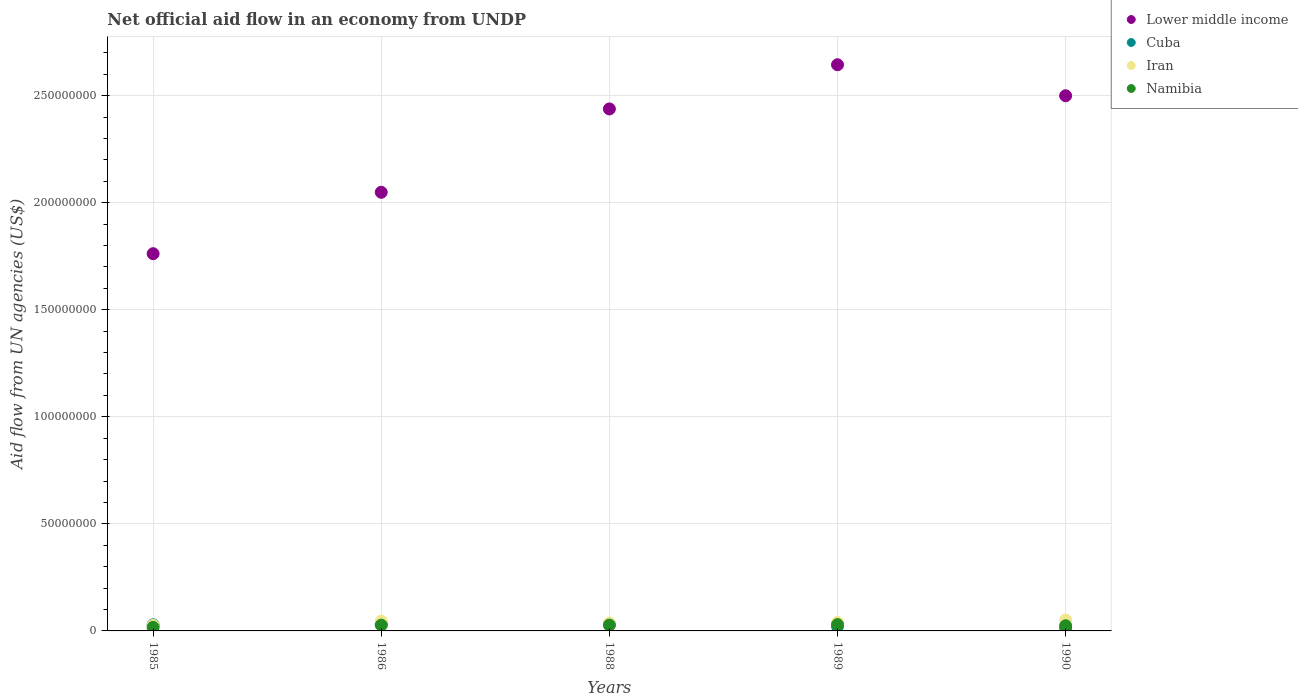What is the net official aid flow in Namibia in 1988?
Your response must be concise. 2.71e+06. Across all years, what is the maximum net official aid flow in Cuba?
Offer a terse response. 3.24e+06. Across all years, what is the minimum net official aid flow in Iran?
Give a very brief answer. 2.56e+06. What is the total net official aid flow in Cuba in the graph?
Provide a succinct answer. 1.27e+07. What is the difference between the net official aid flow in Lower middle income in 1985 and that in 1986?
Make the answer very short. -2.87e+07. What is the difference between the net official aid flow in Namibia in 1989 and the net official aid flow in Cuba in 1990?
Provide a short and direct response. 1.66e+06. What is the average net official aid flow in Lower middle income per year?
Offer a very short reply. 2.28e+08. In the year 1989, what is the difference between the net official aid flow in Iran and net official aid flow in Cuba?
Keep it short and to the point. 1.77e+06. What is the ratio of the net official aid flow in Namibia in 1989 to that in 1990?
Make the answer very short. 1.23. Is the difference between the net official aid flow in Iran in 1986 and 1989 greater than the difference between the net official aid flow in Cuba in 1986 and 1989?
Make the answer very short. No. What is the difference between the highest and the second highest net official aid flow in Lower middle income?
Provide a short and direct response. 1.45e+07. What is the difference between the highest and the lowest net official aid flow in Iran?
Give a very brief answer. 2.55e+06. In how many years, is the net official aid flow in Cuba greater than the average net official aid flow in Cuba taken over all years?
Provide a succinct answer. 3. Is the sum of the net official aid flow in Namibia in 1985 and 1989 greater than the maximum net official aid flow in Lower middle income across all years?
Keep it short and to the point. No. Is it the case that in every year, the sum of the net official aid flow in Iran and net official aid flow in Namibia  is greater than the net official aid flow in Lower middle income?
Give a very brief answer. No. Does the net official aid flow in Cuba monotonically increase over the years?
Offer a terse response. No. Is the net official aid flow in Namibia strictly greater than the net official aid flow in Lower middle income over the years?
Provide a short and direct response. No. Is the net official aid flow in Iran strictly less than the net official aid flow in Namibia over the years?
Give a very brief answer. No. How many dotlines are there?
Offer a terse response. 4. How many years are there in the graph?
Your answer should be very brief. 5. Are the values on the major ticks of Y-axis written in scientific E-notation?
Provide a succinct answer. No. Does the graph contain grids?
Your answer should be very brief. Yes. How are the legend labels stacked?
Your answer should be compact. Vertical. What is the title of the graph?
Make the answer very short. Net official aid flow in an economy from UNDP. What is the label or title of the X-axis?
Offer a terse response. Years. What is the label or title of the Y-axis?
Your answer should be very brief. Aid flow from UN agencies (US$). What is the Aid flow from UN agencies (US$) of Lower middle income in 1985?
Give a very brief answer. 1.76e+08. What is the Aid flow from UN agencies (US$) in Cuba in 1985?
Offer a terse response. 2.86e+06. What is the Aid flow from UN agencies (US$) of Iran in 1985?
Your response must be concise. 2.56e+06. What is the Aid flow from UN agencies (US$) in Namibia in 1985?
Offer a very short reply. 1.66e+06. What is the Aid flow from UN agencies (US$) in Lower middle income in 1986?
Offer a terse response. 2.05e+08. What is the Aid flow from UN agencies (US$) in Cuba in 1986?
Make the answer very short. 3.24e+06. What is the Aid flow from UN agencies (US$) of Iran in 1986?
Keep it short and to the point. 4.57e+06. What is the Aid flow from UN agencies (US$) in Namibia in 1986?
Make the answer very short. 2.71e+06. What is the Aid flow from UN agencies (US$) in Lower middle income in 1988?
Keep it short and to the point. 2.44e+08. What is the Aid flow from UN agencies (US$) in Cuba in 1988?
Your answer should be compact. 3.16e+06. What is the Aid flow from UN agencies (US$) of Iran in 1988?
Keep it short and to the point. 3.69e+06. What is the Aid flow from UN agencies (US$) in Namibia in 1988?
Your response must be concise. 2.71e+06. What is the Aid flow from UN agencies (US$) in Lower middle income in 1989?
Provide a short and direct response. 2.64e+08. What is the Aid flow from UN agencies (US$) in Cuba in 1989?
Provide a short and direct response. 2.15e+06. What is the Aid flow from UN agencies (US$) in Iran in 1989?
Provide a short and direct response. 3.92e+06. What is the Aid flow from UN agencies (US$) of Namibia in 1989?
Ensure brevity in your answer.  2.96e+06. What is the Aid flow from UN agencies (US$) of Lower middle income in 1990?
Offer a terse response. 2.50e+08. What is the Aid flow from UN agencies (US$) in Cuba in 1990?
Your response must be concise. 1.30e+06. What is the Aid flow from UN agencies (US$) in Iran in 1990?
Offer a very short reply. 5.11e+06. What is the Aid flow from UN agencies (US$) of Namibia in 1990?
Your answer should be very brief. 2.41e+06. Across all years, what is the maximum Aid flow from UN agencies (US$) of Lower middle income?
Offer a terse response. 2.64e+08. Across all years, what is the maximum Aid flow from UN agencies (US$) of Cuba?
Offer a very short reply. 3.24e+06. Across all years, what is the maximum Aid flow from UN agencies (US$) in Iran?
Your answer should be very brief. 5.11e+06. Across all years, what is the maximum Aid flow from UN agencies (US$) in Namibia?
Provide a succinct answer. 2.96e+06. Across all years, what is the minimum Aid flow from UN agencies (US$) in Lower middle income?
Give a very brief answer. 1.76e+08. Across all years, what is the minimum Aid flow from UN agencies (US$) of Cuba?
Keep it short and to the point. 1.30e+06. Across all years, what is the minimum Aid flow from UN agencies (US$) of Iran?
Your answer should be compact. 2.56e+06. Across all years, what is the minimum Aid flow from UN agencies (US$) of Namibia?
Your response must be concise. 1.66e+06. What is the total Aid flow from UN agencies (US$) of Lower middle income in the graph?
Offer a very short reply. 1.14e+09. What is the total Aid flow from UN agencies (US$) of Cuba in the graph?
Your answer should be very brief. 1.27e+07. What is the total Aid flow from UN agencies (US$) of Iran in the graph?
Make the answer very short. 1.98e+07. What is the total Aid flow from UN agencies (US$) in Namibia in the graph?
Your answer should be compact. 1.24e+07. What is the difference between the Aid flow from UN agencies (US$) of Lower middle income in 1985 and that in 1986?
Offer a terse response. -2.87e+07. What is the difference between the Aid flow from UN agencies (US$) of Cuba in 1985 and that in 1986?
Your response must be concise. -3.80e+05. What is the difference between the Aid flow from UN agencies (US$) in Iran in 1985 and that in 1986?
Give a very brief answer. -2.01e+06. What is the difference between the Aid flow from UN agencies (US$) in Namibia in 1985 and that in 1986?
Give a very brief answer. -1.05e+06. What is the difference between the Aid flow from UN agencies (US$) of Lower middle income in 1985 and that in 1988?
Provide a succinct answer. -6.76e+07. What is the difference between the Aid flow from UN agencies (US$) in Iran in 1985 and that in 1988?
Offer a terse response. -1.13e+06. What is the difference between the Aid flow from UN agencies (US$) of Namibia in 1985 and that in 1988?
Provide a short and direct response. -1.05e+06. What is the difference between the Aid flow from UN agencies (US$) in Lower middle income in 1985 and that in 1989?
Give a very brief answer. -8.82e+07. What is the difference between the Aid flow from UN agencies (US$) in Cuba in 1985 and that in 1989?
Offer a very short reply. 7.10e+05. What is the difference between the Aid flow from UN agencies (US$) in Iran in 1985 and that in 1989?
Provide a short and direct response. -1.36e+06. What is the difference between the Aid flow from UN agencies (US$) in Namibia in 1985 and that in 1989?
Ensure brevity in your answer.  -1.30e+06. What is the difference between the Aid flow from UN agencies (US$) of Lower middle income in 1985 and that in 1990?
Offer a terse response. -7.38e+07. What is the difference between the Aid flow from UN agencies (US$) of Cuba in 1985 and that in 1990?
Give a very brief answer. 1.56e+06. What is the difference between the Aid flow from UN agencies (US$) of Iran in 1985 and that in 1990?
Your response must be concise. -2.55e+06. What is the difference between the Aid flow from UN agencies (US$) in Namibia in 1985 and that in 1990?
Offer a terse response. -7.50e+05. What is the difference between the Aid flow from UN agencies (US$) in Lower middle income in 1986 and that in 1988?
Your answer should be very brief. -3.89e+07. What is the difference between the Aid flow from UN agencies (US$) in Cuba in 1986 and that in 1988?
Your answer should be compact. 8.00e+04. What is the difference between the Aid flow from UN agencies (US$) in Iran in 1986 and that in 1988?
Provide a succinct answer. 8.80e+05. What is the difference between the Aid flow from UN agencies (US$) of Lower middle income in 1986 and that in 1989?
Give a very brief answer. -5.96e+07. What is the difference between the Aid flow from UN agencies (US$) in Cuba in 1986 and that in 1989?
Your response must be concise. 1.09e+06. What is the difference between the Aid flow from UN agencies (US$) in Iran in 1986 and that in 1989?
Give a very brief answer. 6.50e+05. What is the difference between the Aid flow from UN agencies (US$) of Lower middle income in 1986 and that in 1990?
Offer a terse response. -4.51e+07. What is the difference between the Aid flow from UN agencies (US$) of Cuba in 1986 and that in 1990?
Your answer should be compact. 1.94e+06. What is the difference between the Aid flow from UN agencies (US$) in Iran in 1986 and that in 1990?
Offer a very short reply. -5.40e+05. What is the difference between the Aid flow from UN agencies (US$) in Lower middle income in 1988 and that in 1989?
Your answer should be very brief. -2.06e+07. What is the difference between the Aid flow from UN agencies (US$) of Cuba in 1988 and that in 1989?
Ensure brevity in your answer.  1.01e+06. What is the difference between the Aid flow from UN agencies (US$) in Iran in 1988 and that in 1989?
Your response must be concise. -2.30e+05. What is the difference between the Aid flow from UN agencies (US$) of Lower middle income in 1988 and that in 1990?
Ensure brevity in your answer.  -6.16e+06. What is the difference between the Aid flow from UN agencies (US$) in Cuba in 1988 and that in 1990?
Make the answer very short. 1.86e+06. What is the difference between the Aid flow from UN agencies (US$) in Iran in 1988 and that in 1990?
Your answer should be compact. -1.42e+06. What is the difference between the Aid flow from UN agencies (US$) in Namibia in 1988 and that in 1990?
Your answer should be compact. 3.00e+05. What is the difference between the Aid flow from UN agencies (US$) in Lower middle income in 1989 and that in 1990?
Provide a succinct answer. 1.45e+07. What is the difference between the Aid flow from UN agencies (US$) of Cuba in 1989 and that in 1990?
Offer a terse response. 8.50e+05. What is the difference between the Aid flow from UN agencies (US$) of Iran in 1989 and that in 1990?
Provide a short and direct response. -1.19e+06. What is the difference between the Aid flow from UN agencies (US$) in Lower middle income in 1985 and the Aid flow from UN agencies (US$) in Cuba in 1986?
Keep it short and to the point. 1.73e+08. What is the difference between the Aid flow from UN agencies (US$) in Lower middle income in 1985 and the Aid flow from UN agencies (US$) in Iran in 1986?
Your answer should be compact. 1.72e+08. What is the difference between the Aid flow from UN agencies (US$) of Lower middle income in 1985 and the Aid flow from UN agencies (US$) of Namibia in 1986?
Your response must be concise. 1.73e+08. What is the difference between the Aid flow from UN agencies (US$) of Cuba in 1985 and the Aid flow from UN agencies (US$) of Iran in 1986?
Your answer should be compact. -1.71e+06. What is the difference between the Aid flow from UN agencies (US$) of Cuba in 1985 and the Aid flow from UN agencies (US$) of Namibia in 1986?
Offer a terse response. 1.50e+05. What is the difference between the Aid flow from UN agencies (US$) in Iran in 1985 and the Aid flow from UN agencies (US$) in Namibia in 1986?
Provide a succinct answer. -1.50e+05. What is the difference between the Aid flow from UN agencies (US$) in Lower middle income in 1985 and the Aid flow from UN agencies (US$) in Cuba in 1988?
Provide a short and direct response. 1.73e+08. What is the difference between the Aid flow from UN agencies (US$) in Lower middle income in 1985 and the Aid flow from UN agencies (US$) in Iran in 1988?
Give a very brief answer. 1.72e+08. What is the difference between the Aid flow from UN agencies (US$) in Lower middle income in 1985 and the Aid flow from UN agencies (US$) in Namibia in 1988?
Your answer should be very brief. 1.73e+08. What is the difference between the Aid flow from UN agencies (US$) of Cuba in 1985 and the Aid flow from UN agencies (US$) of Iran in 1988?
Provide a succinct answer. -8.30e+05. What is the difference between the Aid flow from UN agencies (US$) in Cuba in 1985 and the Aid flow from UN agencies (US$) in Namibia in 1988?
Give a very brief answer. 1.50e+05. What is the difference between the Aid flow from UN agencies (US$) in Iran in 1985 and the Aid flow from UN agencies (US$) in Namibia in 1988?
Keep it short and to the point. -1.50e+05. What is the difference between the Aid flow from UN agencies (US$) in Lower middle income in 1985 and the Aid flow from UN agencies (US$) in Cuba in 1989?
Provide a short and direct response. 1.74e+08. What is the difference between the Aid flow from UN agencies (US$) in Lower middle income in 1985 and the Aid flow from UN agencies (US$) in Iran in 1989?
Offer a terse response. 1.72e+08. What is the difference between the Aid flow from UN agencies (US$) of Lower middle income in 1985 and the Aid flow from UN agencies (US$) of Namibia in 1989?
Offer a very short reply. 1.73e+08. What is the difference between the Aid flow from UN agencies (US$) in Cuba in 1985 and the Aid flow from UN agencies (US$) in Iran in 1989?
Keep it short and to the point. -1.06e+06. What is the difference between the Aid flow from UN agencies (US$) in Cuba in 1985 and the Aid flow from UN agencies (US$) in Namibia in 1989?
Give a very brief answer. -1.00e+05. What is the difference between the Aid flow from UN agencies (US$) of Iran in 1985 and the Aid flow from UN agencies (US$) of Namibia in 1989?
Keep it short and to the point. -4.00e+05. What is the difference between the Aid flow from UN agencies (US$) in Lower middle income in 1985 and the Aid flow from UN agencies (US$) in Cuba in 1990?
Your answer should be very brief. 1.75e+08. What is the difference between the Aid flow from UN agencies (US$) of Lower middle income in 1985 and the Aid flow from UN agencies (US$) of Iran in 1990?
Ensure brevity in your answer.  1.71e+08. What is the difference between the Aid flow from UN agencies (US$) of Lower middle income in 1985 and the Aid flow from UN agencies (US$) of Namibia in 1990?
Provide a short and direct response. 1.74e+08. What is the difference between the Aid flow from UN agencies (US$) in Cuba in 1985 and the Aid flow from UN agencies (US$) in Iran in 1990?
Offer a terse response. -2.25e+06. What is the difference between the Aid flow from UN agencies (US$) in Iran in 1985 and the Aid flow from UN agencies (US$) in Namibia in 1990?
Your answer should be compact. 1.50e+05. What is the difference between the Aid flow from UN agencies (US$) of Lower middle income in 1986 and the Aid flow from UN agencies (US$) of Cuba in 1988?
Give a very brief answer. 2.02e+08. What is the difference between the Aid flow from UN agencies (US$) in Lower middle income in 1986 and the Aid flow from UN agencies (US$) in Iran in 1988?
Provide a succinct answer. 2.01e+08. What is the difference between the Aid flow from UN agencies (US$) of Lower middle income in 1986 and the Aid flow from UN agencies (US$) of Namibia in 1988?
Keep it short and to the point. 2.02e+08. What is the difference between the Aid flow from UN agencies (US$) in Cuba in 1986 and the Aid flow from UN agencies (US$) in Iran in 1988?
Give a very brief answer. -4.50e+05. What is the difference between the Aid flow from UN agencies (US$) of Cuba in 1986 and the Aid flow from UN agencies (US$) of Namibia in 1988?
Your answer should be compact. 5.30e+05. What is the difference between the Aid flow from UN agencies (US$) of Iran in 1986 and the Aid flow from UN agencies (US$) of Namibia in 1988?
Your answer should be compact. 1.86e+06. What is the difference between the Aid flow from UN agencies (US$) in Lower middle income in 1986 and the Aid flow from UN agencies (US$) in Cuba in 1989?
Keep it short and to the point. 2.03e+08. What is the difference between the Aid flow from UN agencies (US$) of Lower middle income in 1986 and the Aid flow from UN agencies (US$) of Iran in 1989?
Provide a succinct answer. 2.01e+08. What is the difference between the Aid flow from UN agencies (US$) of Lower middle income in 1986 and the Aid flow from UN agencies (US$) of Namibia in 1989?
Your answer should be very brief. 2.02e+08. What is the difference between the Aid flow from UN agencies (US$) of Cuba in 1986 and the Aid flow from UN agencies (US$) of Iran in 1989?
Ensure brevity in your answer.  -6.80e+05. What is the difference between the Aid flow from UN agencies (US$) of Cuba in 1986 and the Aid flow from UN agencies (US$) of Namibia in 1989?
Offer a very short reply. 2.80e+05. What is the difference between the Aid flow from UN agencies (US$) in Iran in 1986 and the Aid flow from UN agencies (US$) in Namibia in 1989?
Ensure brevity in your answer.  1.61e+06. What is the difference between the Aid flow from UN agencies (US$) in Lower middle income in 1986 and the Aid flow from UN agencies (US$) in Cuba in 1990?
Keep it short and to the point. 2.04e+08. What is the difference between the Aid flow from UN agencies (US$) of Lower middle income in 1986 and the Aid flow from UN agencies (US$) of Iran in 1990?
Offer a terse response. 2.00e+08. What is the difference between the Aid flow from UN agencies (US$) in Lower middle income in 1986 and the Aid flow from UN agencies (US$) in Namibia in 1990?
Make the answer very short. 2.02e+08. What is the difference between the Aid flow from UN agencies (US$) in Cuba in 1986 and the Aid flow from UN agencies (US$) in Iran in 1990?
Give a very brief answer. -1.87e+06. What is the difference between the Aid flow from UN agencies (US$) in Cuba in 1986 and the Aid flow from UN agencies (US$) in Namibia in 1990?
Offer a terse response. 8.30e+05. What is the difference between the Aid flow from UN agencies (US$) in Iran in 1986 and the Aid flow from UN agencies (US$) in Namibia in 1990?
Your answer should be very brief. 2.16e+06. What is the difference between the Aid flow from UN agencies (US$) of Lower middle income in 1988 and the Aid flow from UN agencies (US$) of Cuba in 1989?
Make the answer very short. 2.42e+08. What is the difference between the Aid flow from UN agencies (US$) of Lower middle income in 1988 and the Aid flow from UN agencies (US$) of Iran in 1989?
Your response must be concise. 2.40e+08. What is the difference between the Aid flow from UN agencies (US$) of Lower middle income in 1988 and the Aid flow from UN agencies (US$) of Namibia in 1989?
Your answer should be very brief. 2.41e+08. What is the difference between the Aid flow from UN agencies (US$) of Cuba in 1988 and the Aid flow from UN agencies (US$) of Iran in 1989?
Your answer should be compact. -7.60e+05. What is the difference between the Aid flow from UN agencies (US$) of Iran in 1988 and the Aid flow from UN agencies (US$) of Namibia in 1989?
Offer a terse response. 7.30e+05. What is the difference between the Aid flow from UN agencies (US$) in Lower middle income in 1988 and the Aid flow from UN agencies (US$) in Cuba in 1990?
Offer a terse response. 2.42e+08. What is the difference between the Aid flow from UN agencies (US$) of Lower middle income in 1988 and the Aid flow from UN agencies (US$) of Iran in 1990?
Offer a very short reply. 2.39e+08. What is the difference between the Aid flow from UN agencies (US$) in Lower middle income in 1988 and the Aid flow from UN agencies (US$) in Namibia in 1990?
Offer a terse response. 2.41e+08. What is the difference between the Aid flow from UN agencies (US$) in Cuba in 1988 and the Aid flow from UN agencies (US$) in Iran in 1990?
Offer a terse response. -1.95e+06. What is the difference between the Aid flow from UN agencies (US$) of Cuba in 1988 and the Aid flow from UN agencies (US$) of Namibia in 1990?
Offer a very short reply. 7.50e+05. What is the difference between the Aid flow from UN agencies (US$) in Iran in 1988 and the Aid flow from UN agencies (US$) in Namibia in 1990?
Give a very brief answer. 1.28e+06. What is the difference between the Aid flow from UN agencies (US$) of Lower middle income in 1989 and the Aid flow from UN agencies (US$) of Cuba in 1990?
Your answer should be compact. 2.63e+08. What is the difference between the Aid flow from UN agencies (US$) in Lower middle income in 1989 and the Aid flow from UN agencies (US$) in Iran in 1990?
Provide a short and direct response. 2.59e+08. What is the difference between the Aid flow from UN agencies (US$) in Lower middle income in 1989 and the Aid flow from UN agencies (US$) in Namibia in 1990?
Offer a terse response. 2.62e+08. What is the difference between the Aid flow from UN agencies (US$) of Cuba in 1989 and the Aid flow from UN agencies (US$) of Iran in 1990?
Your answer should be compact. -2.96e+06. What is the difference between the Aid flow from UN agencies (US$) in Iran in 1989 and the Aid flow from UN agencies (US$) in Namibia in 1990?
Ensure brevity in your answer.  1.51e+06. What is the average Aid flow from UN agencies (US$) of Lower middle income per year?
Your answer should be compact. 2.28e+08. What is the average Aid flow from UN agencies (US$) of Cuba per year?
Give a very brief answer. 2.54e+06. What is the average Aid flow from UN agencies (US$) of Iran per year?
Give a very brief answer. 3.97e+06. What is the average Aid flow from UN agencies (US$) of Namibia per year?
Provide a succinct answer. 2.49e+06. In the year 1985, what is the difference between the Aid flow from UN agencies (US$) of Lower middle income and Aid flow from UN agencies (US$) of Cuba?
Give a very brief answer. 1.73e+08. In the year 1985, what is the difference between the Aid flow from UN agencies (US$) in Lower middle income and Aid flow from UN agencies (US$) in Iran?
Give a very brief answer. 1.74e+08. In the year 1985, what is the difference between the Aid flow from UN agencies (US$) in Lower middle income and Aid flow from UN agencies (US$) in Namibia?
Your answer should be very brief. 1.75e+08. In the year 1985, what is the difference between the Aid flow from UN agencies (US$) of Cuba and Aid flow from UN agencies (US$) of Iran?
Offer a terse response. 3.00e+05. In the year 1985, what is the difference between the Aid flow from UN agencies (US$) in Cuba and Aid flow from UN agencies (US$) in Namibia?
Provide a short and direct response. 1.20e+06. In the year 1986, what is the difference between the Aid flow from UN agencies (US$) in Lower middle income and Aid flow from UN agencies (US$) in Cuba?
Provide a short and direct response. 2.02e+08. In the year 1986, what is the difference between the Aid flow from UN agencies (US$) in Lower middle income and Aid flow from UN agencies (US$) in Iran?
Ensure brevity in your answer.  2.00e+08. In the year 1986, what is the difference between the Aid flow from UN agencies (US$) of Lower middle income and Aid flow from UN agencies (US$) of Namibia?
Offer a very short reply. 2.02e+08. In the year 1986, what is the difference between the Aid flow from UN agencies (US$) in Cuba and Aid flow from UN agencies (US$) in Iran?
Give a very brief answer. -1.33e+06. In the year 1986, what is the difference between the Aid flow from UN agencies (US$) of Cuba and Aid flow from UN agencies (US$) of Namibia?
Offer a terse response. 5.30e+05. In the year 1986, what is the difference between the Aid flow from UN agencies (US$) of Iran and Aid flow from UN agencies (US$) of Namibia?
Your answer should be very brief. 1.86e+06. In the year 1988, what is the difference between the Aid flow from UN agencies (US$) of Lower middle income and Aid flow from UN agencies (US$) of Cuba?
Make the answer very short. 2.41e+08. In the year 1988, what is the difference between the Aid flow from UN agencies (US$) of Lower middle income and Aid flow from UN agencies (US$) of Iran?
Provide a succinct answer. 2.40e+08. In the year 1988, what is the difference between the Aid flow from UN agencies (US$) in Lower middle income and Aid flow from UN agencies (US$) in Namibia?
Keep it short and to the point. 2.41e+08. In the year 1988, what is the difference between the Aid flow from UN agencies (US$) of Cuba and Aid flow from UN agencies (US$) of Iran?
Your answer should be very brief. -5.30e+05. In the year 1988, what is the difference between the Aid flow from UN agencies (US$) of Iran and Aid flow from UN agencies (US$) of Namibia?
Offer a terse response. 9.80e+05. In the year 1989, what is the difference between the Aid flow from UN agencies (US$) of Lower middle income and Aid flow from UN agencies (US$) of Cuba?
Your response must be concise. 2.62e+08. In the year 1989, what is the difference between the Aid flow from UN agencies (US$) of Lower middle income and Aid flow from UN agencies (US$) of Iran?
Offer a terse response. 2.61e+08. In the year 1989, what is the difference between the Aid flow from UN agencies (US$) of Lower middle income and Aid flow from UN agencies (US$) of Namibia?
Your response must be concise. 2.61e+08. In the year 1989, what is the difference between the Aid flow from UN agencies (US$) of Cuba and Aid flow from UN agencies (US$) of Iran?
Your answer should be compact. -1.77e+06. In the year 1989, what is the difference between the Aid flow from UN agencies (US$) of Cuba and Aid flow from UN agencies (US$) of Namibia?
Give a very brief answer. -8.10e+05. In the year 1989, what is the difference between the Aid flow from UN agencies (US$) of Iran and Aid flow from UN agencies (US$) of Namibia?
Ensure brevity in your answer.  9.60e+05. In the year 1990, what is the difference between the Aid flow from UN agencies (US$) of Lower middle income and Aid flow from UN agencies (US$) of Cuba?
Your answer should be very brief. 2.49e+08. In the year 1990, what is the difference between the Aid flow from UN agencies (US$) in Lower middle income and Aid flow from UN agencies (US$) in Iran?
Provide a succinct answer. 2.45e+08. In the year 1990, what is the difference between the Aid flow from UN agencies (US$) in Lower middle income and Aid flow from UN agencies (US$) in Namibia?
Your response must be concise. 2.48e+08. In the year 1990, what is the difference between the Aid flow from UN agencies (US$) in Cuba and Aid flow from UN agencies (US$) in Iran?
Keep it short and to the point. -3.81e+06. In the year 1990, what is the difference between the Aid flow from UN agencies (US$) of Cuba and Aid flow from UN agencies (US$) of Namibia?
Your response must be concise. -1.11e+06. In the year 1990, what is the difference between the Aid flow from UN agencies (US$) in Iran and Aid flow from UN agencies (US$) in Namibia?
Your answer should be very brief. 2.70e+06. What is the ratio of the Aid flow from UN agencies (US$) in Lower middle income in 1985 to that in 1986?
Keep it short and to the point. 0.86. What is the ratio of the Aid flow from UN agencies (US$) of Cuba in 1985 to that in 1986?
Provide a succinct answer. 0.88. What is the ratio of the Aid flow from UN agencies (US$) of Iran in 1985 to that in 1986?
Make the answer very short. 0.56. What is the ratio of the Aid flow from UN agencies (US$) of Namibia in 1985 to that in 1986?
Keep it short and to the point. 0.61. What is the ratio of the Aid flow from UN agencies (US$) of Lower middle income in 1985 to that in 1988?
Offer a terse response. 0.72. What is the ratio of the Aid flow from UN agencies (US$) of Cuba in 1985 to that in 1988?
Make the answer very short. 0.91. What is the ratio of the Aid flow from UN agencies (US$) of Iran in 1985 to that in 1988?
Your response must be concise. 0.69. What is the ratio of the Aid flow from UN agencies (US$) of Namibia in 1985 to that in 1988?
Keep it short and to the point. 0.61. What is the ratio of the Aid flow from UN agencies (US$) of Lower middle income in 1985 to that in 1989?
Offer a very short reply. 0.67. What is the ratio of the Aid flow from UN agencies (US$) in Cuba in 1985 to that in 1989?
Offer a terse response. 1.33. What is the ratio of the Aid flow from UN agencies (US$) in Iran in 1985 to that in 1989?
Give a very brief answer. 0.65. What is the ratio of the Aid flow from UN agencies (US$) in Namibia in 1985 to that in 1989?
Your response must be concise. 0.56. What is the ratio of the Aid flow from UN agencies (US$) in Lower middle income in 1985 to that in 1990?
Provide a short and direct response. 0.7. What is the ratio of the Aid flow from UN agencies (US$) of Iran in 1985 to that in 1990?
Provide a succinct answer. 0.5. What is the ratio of the Aid flow from UN agencies (US$) in Namibia in 1985 to that in 1990?
Offer a terse response. 0.69. What is the ratio of the Aid flow from UN agencies (US$) in Lower middle income in 1986 to that in 1988?
Your answer should be compact. 0.84. What is the ratio of the Aid flow from UN agencies (US$) in Cuba in 1986 to that in 1988?
Your response must be concise. 1.03. What is the ratio of the Aid flow from UN agencies (US$) in Iran in 1986 to that in 1988?
Offer a very short reply. 1.24. What is the ratio of the Aid flow from UN agencies (US$) of Lower middle income in 1986 to that in 1989?
Provide a succinct answer. 0.77. What is the ratio of the Aid flow from UN agencies (US$) in Cuba in 1986 to that in 1989?
Your answer should be compact. 1.51. What is the ratio of the Aid flow from UN agencies (US$) of Iran in 1986 to that in 1989?
Ensure brevity in your answer.  1.17. What is the ratio of the Aid flow from UN agencies (US$) of Namibia in 1986 to that in 1989?
Your answer should be compact. 0.92. What is the ratio of the Aid flow from UN agencies (US$) in Lower middle income in 1986 to that in 1990?
Offer a very short reply. 0.82. What is the ratio of the Aid flow from UN agencies (US$) in Cuba in 1986 to that in 1990?
Keep it short and to the point. 2.49. What is the ratio of the Aid flow from UN agencies (US$) of Iran in 1986 to that in 1990?
Make the answer very short. 0.89. What is the ratio of the Aid flow from UN agencies (US$) of Namibia in 1986 to that in 1990?
Your response must be concise. 1.12. What is the ratio of the Aid flow from UN agencies (US$) of Lower middle income in 1988 to that in 1989?
Make the answer very short. 0.92. What is the ratio of the Aid flow from UN agencies (US$) of Cuba in 1988 to that in 1989?
Give a very brief answer. 1.47. What is the ratio of the Aid flow from UN agencies (US$) of Iran in 1988 to that in 1989?
Ensure brevity in your answer.  0.94. What is the ratio of the Aid flow from UN agencies (US$) of Namibia in 1988 to that in 1989?
Provide a short and direct response. 0.92. What is the ratio of the Aid flow from UN agencies (US$) in Lower middle income in 1988 to that in 1990?
Your answer should be very brief. 0.98. What is the ratio of the Aid flow from UN agencies (US$) in Cuba in 1988 to that in 1990?
Offer a very short reply. 2.43. What is the ratio of the Aid flow from UN agencies (US$) in Iran in 1988 to that in 1990?
Ensure brevity in your answer.  0.72. What is the ratio of the Aid flow from UN agencies (US$) in Namibia in 1988 to that in 1990?
Your answer should be very brief. 1.12. What is the ratio of the Aid flow from UN agencies (US$) of Lower middle income in 1989 to that in 1990?
Offer a very short reply. 1.06. What is the ratio of the Aid flow from UN agencies (US$) in Cuba in 1989 to that in 1990?
Offer a terse response. 1.65. What is the ratio of the Aid flow from UN agencies (US$) in Iran in 1989 to that in 1990?
Keep it short and to the point. 0.77. What is the ratio of the Aid flow from UN agencies (US$) in Namibia in 1989 to that in 1990?
Provide a short and direct response. 1.23. What is the difference between the highest and the second highest Aid flow from UN agencies (US$) of Lower middle income?
Give a very brief answer. 1.45e+07. What is the difference between the highest and the second highest Aid flow from UN agencies (US$) of Iran?
Provide a succinct answer. 5.40e+05. What is the difference between the highest and the second highest Aid flow from UN agencies (US$) in Namibia?
Provide a short and direct response. 2.50e+05. What is the difference between the highest and the lowest Aid flow from UN agencies (US$) in Lower middle income?
Offer a terse response. 8.82e+07. What is the difference between the highest and the lowest Aid flow from UN agencies (US$) of Cuba?
Offer a terse response. 1.94e+06. What is the difference between the highest and the lowest Aid flow from UN agencies (US$) of Iran?
Provide a short and direct response. 2.55e+06. What is the difference between the highest and the lowest Aid flow from UN agencies (US$) in Namibia?
Ensure brevity in your answer.  1.30e+06. 